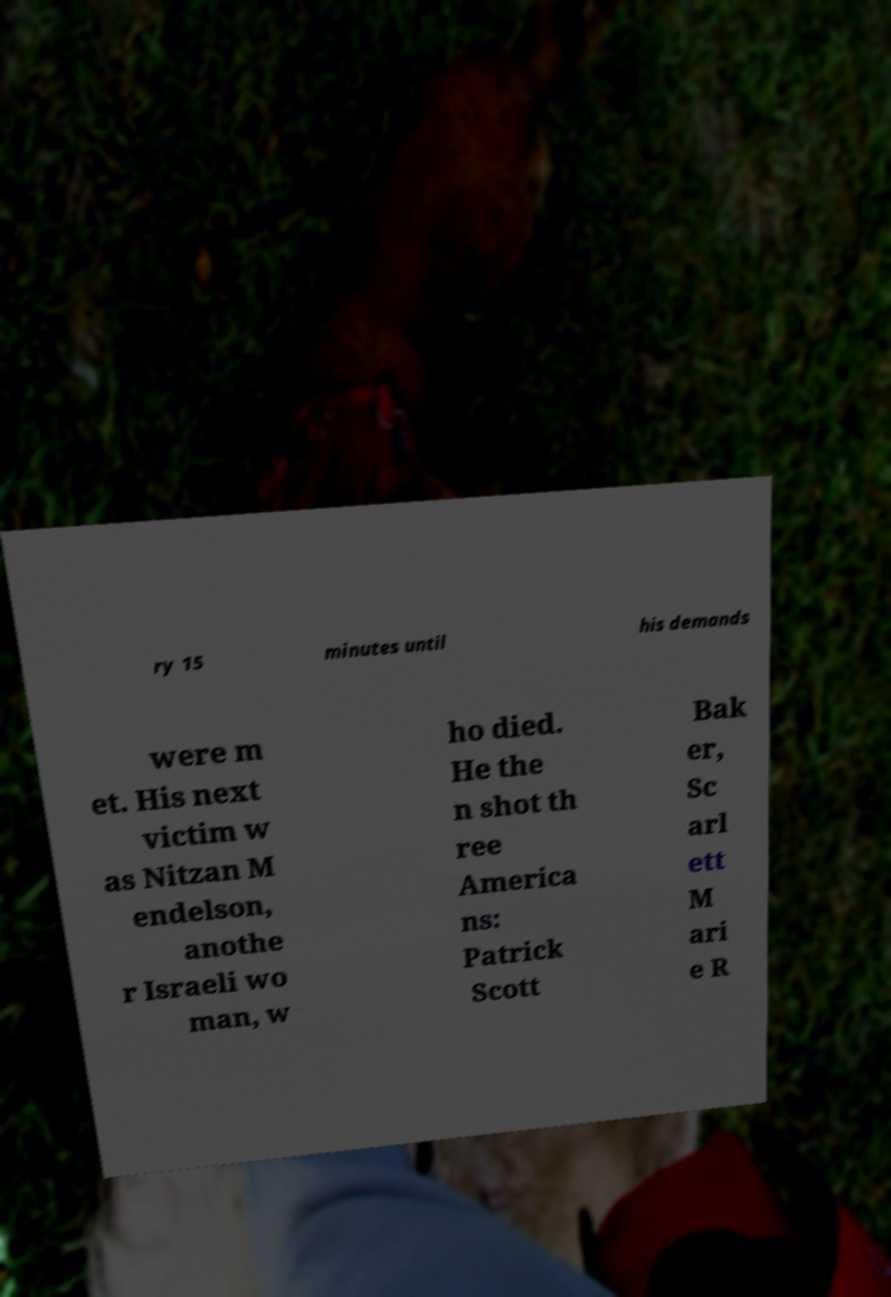What messages or text are displayed in this image? I need them in a readable, typed format. ry 15 minutes until his demands were m et. His next victim w as Nitzan M endelson, anothe r Israeli wo man, w ho died. He the n shot th ree America ns: Patrick Scott Bak er, Sc arl ett M ari e R 